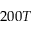<formula> <loc_0><loc_0><loc_500><loc_500>2 0 0 T</formula> 